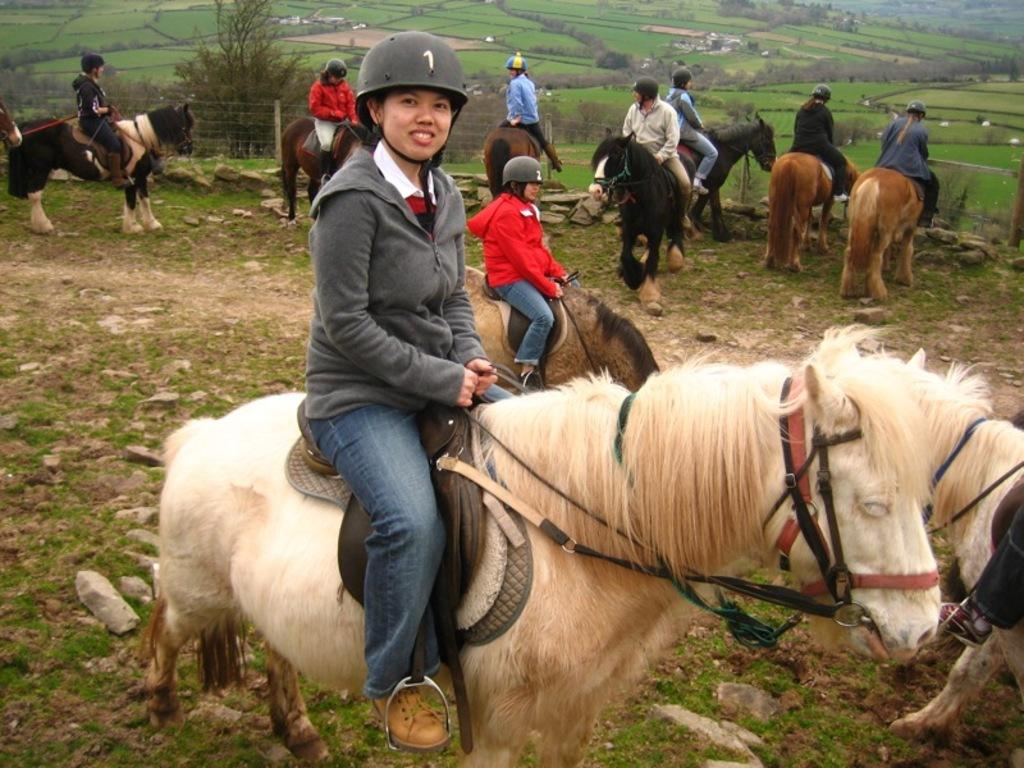What are the people in the image doing? The people in the image are riding horses. What can be seen beneath the horses' hooves? The ground is visible in the image. What type of vegetation is present in the image? There is grass, plants, and trees in the image. What other objects can be seen in the image? There are stones and a fence in the image. What type of soda is being served at the horse riding event in the image? There is no mention of soda or any event in the image; it simply shows people riding horses in a natural setting. 